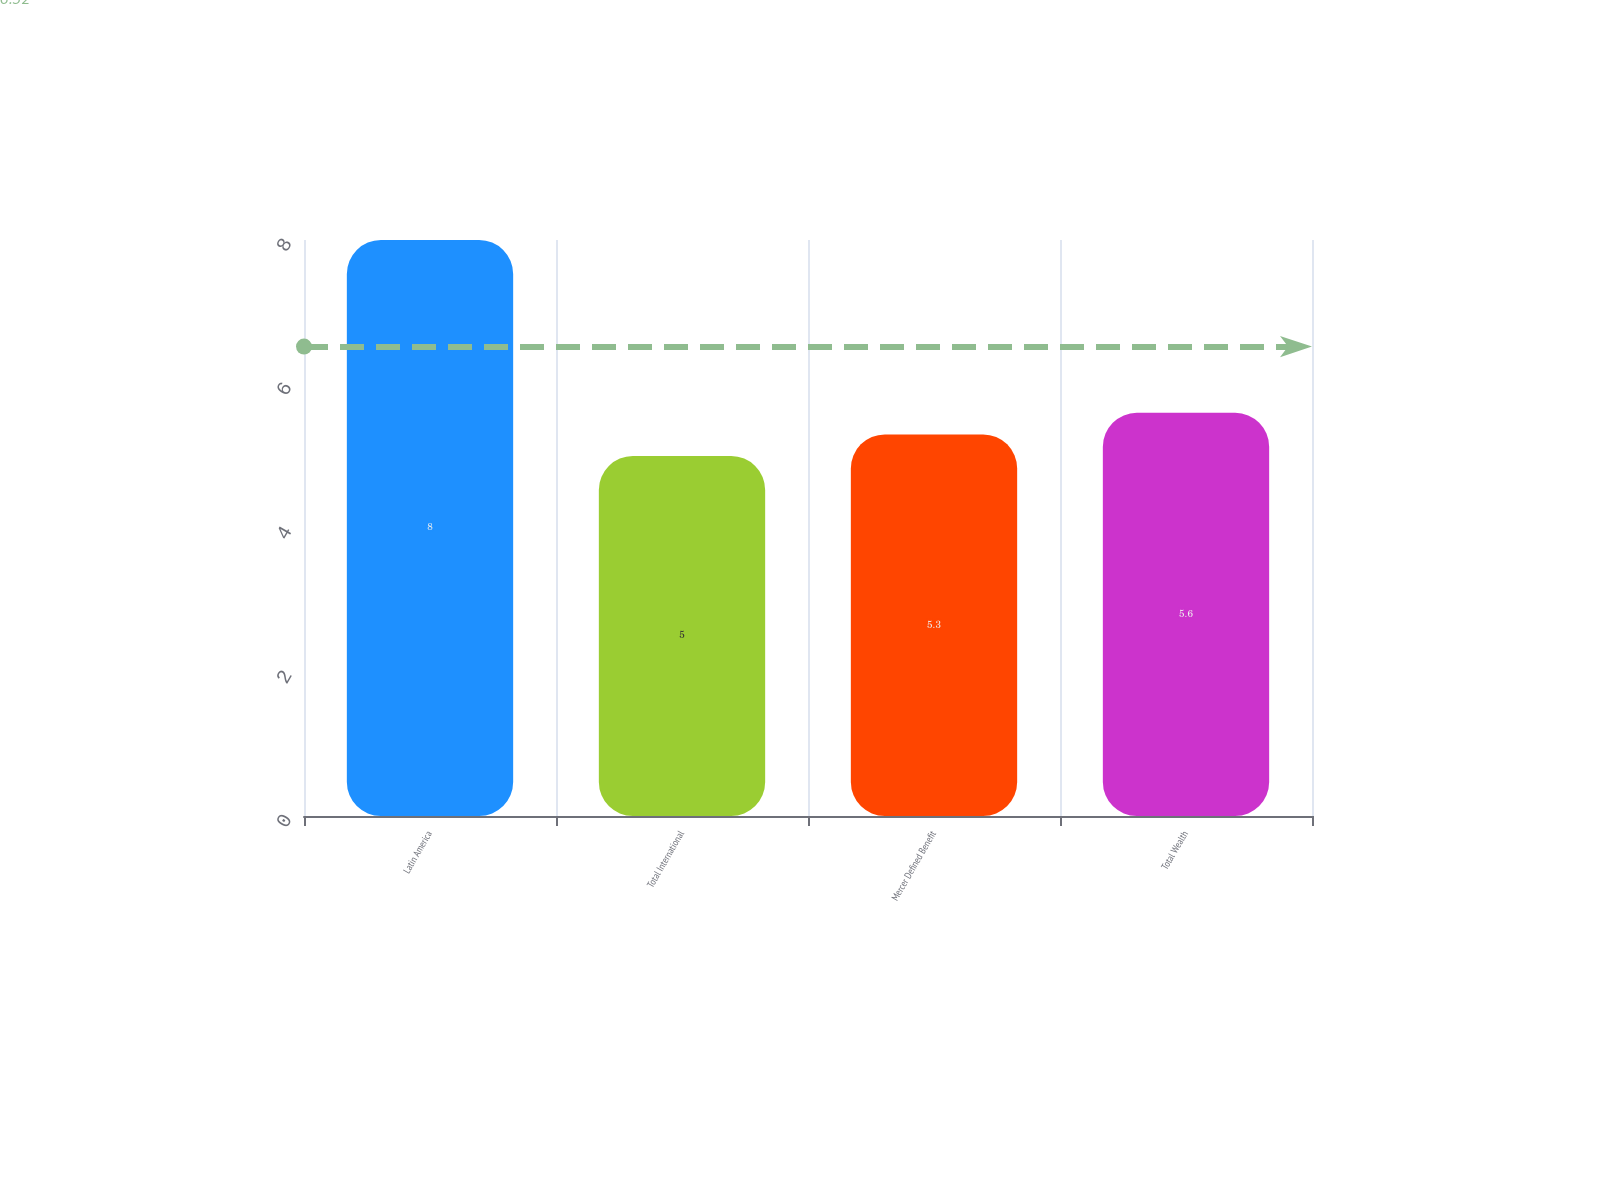Convert chart to OTSL. <chart><loc_0><loc_0><loc_500><loc_500><bar_chart><fcel>Latin America<fcel>Total International<fcel>Mercer Defined Benefit<fcel>Total Wealth<nl><fcel>8<fcel>5<fcel>5.3<fcel>5.6<nl></chart> 